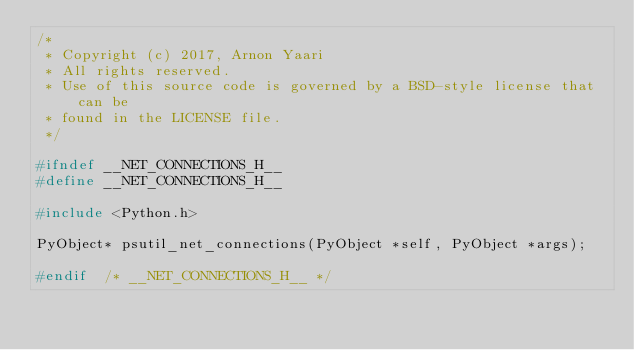Convert code to text. <code><loc_0><loc_0><loc_500><loc_500><_C_>/*
 * Copyright (c) 2017, Arnon Yaari
 * All rights reserved.
 * Use of this source code is governed by a BSD-style license that can be
 * found in the LICENSE file.
 */

#ifndef __NET_CONNECTIONS_H__
#define __NET_CONNECTIONS_H__

#include <Python.h>

PyObject* psutil_net_connections(PyObject *self, PyObject *args);

#endif  /* __NET_CONNECTIONS_H__ */
</code> 